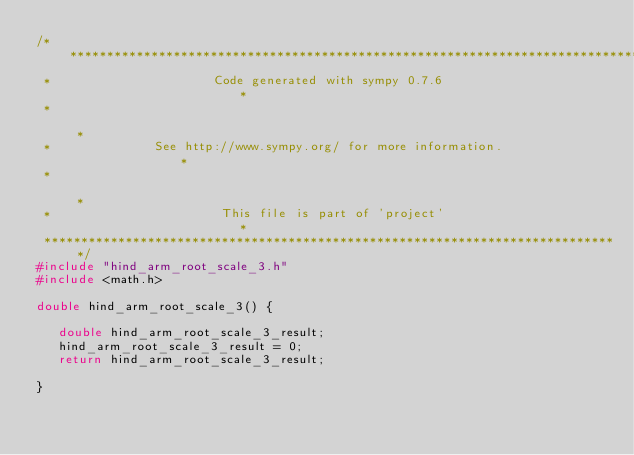Convert code to text. <code><loc_0><loc_0><loc_500><loc_500><_C_>/******************************************************************************
 *                      Code generated with sympy 0.7.6                       *
 *                                                                            *
 *              See http://www.sympy.org/ for more information.               *
 *                                                                            *
 *                       This file is part of 'project'                       *
 ******************************************************************************/
#include "hind_arm_root_scale_3.h"
#include <math.h>

double hind_arm_root_scale_3() {

   double hind_arm_root_scale_3_result;
   hind_arm_root_scale_3_result = 0;
   return hind_arm_root_scale_3_result;

}
</code> 